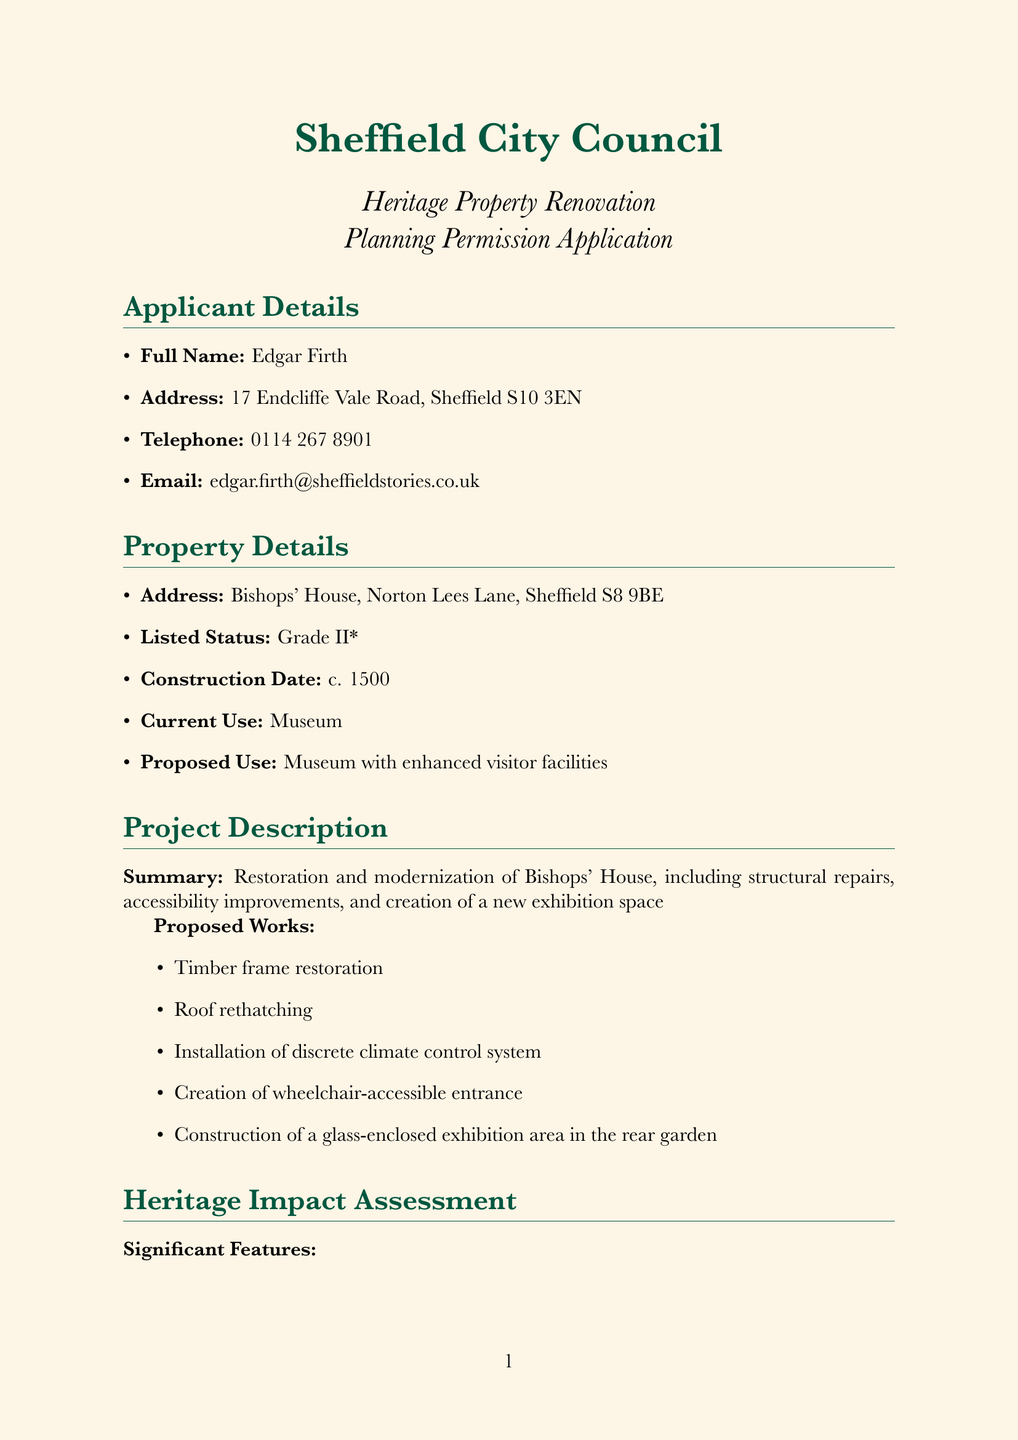What is the applicant's full name? The applicant's full name is stated at the top of the document.
Answer: Edgar Firth What is the address of Bishops' House? The address is provided in the property details section of the document.
Answer: Bishops' House, Norton Lees Lane, Sheffield S8 9BE What is the construction date of the property? The construction date is mentioned in the property details section.
Answer: c. 1500 What is the listed status of Bishops' House? The listed status is specified under property details.
Answer: Grade II* What is one of the significant features of the property? The document lists several significant features under the heritage impact assessment.
Answer: Original 16th-century timber frame What was the recommendation from Historic England? The recommendation from Historic England is found in the consultations section.
Answer: Supportive with conditions What is the purpose of the proposed glass-enclosed exhibition area? This information can be deduced from the project description regarding the proposed works.
Answer: New exhibition space What community benefit is mentioned in the public engagement plans? The community benefits are outlined in the public engagement section of the document.
Answer: Enhanced educational resources What is the date of the signature? The date of the signature is provided in the declaration and signature section.
Answer: 15 May 2023 